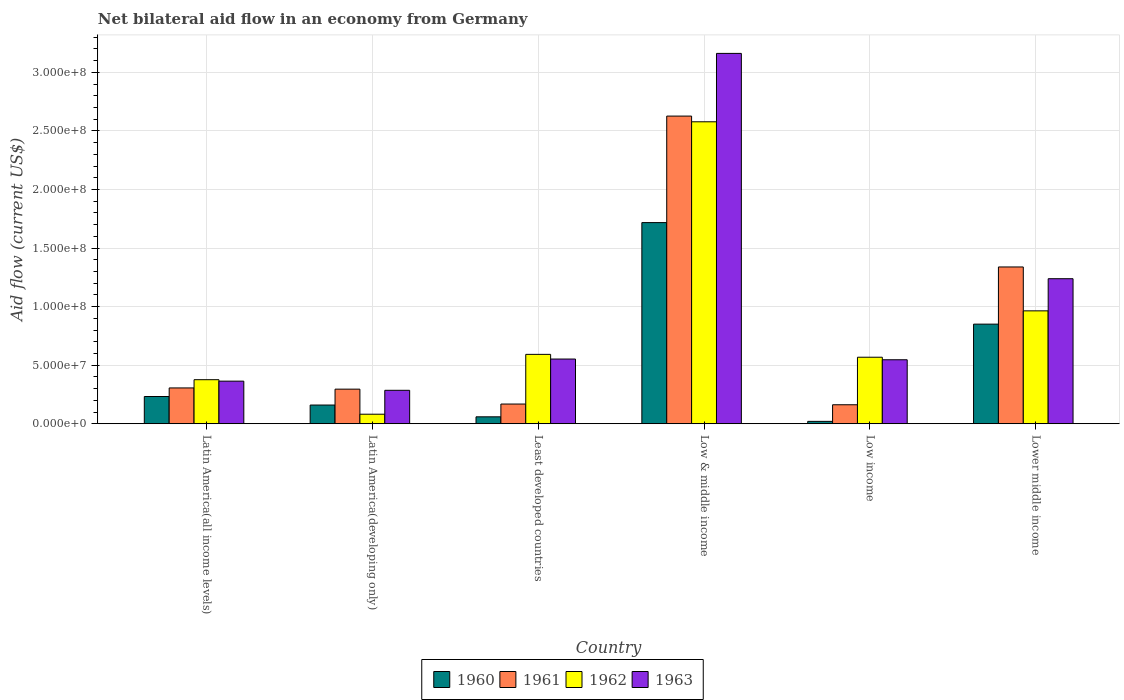How many different coloured bars are there?
Offer a very short reply. 4. How many groups of bars are there?
Ensure brevity in your answer.  6. Are the number of bars per tick equal to the number of legend labels?
Provide a succinct answer. Yes. What is the label of the 1st group of bars from the left?
Your answer should be very brief. Latin America(all income levels). What is the net bilateral aid flow in 1962 in Latin America(developing only)?
Give a very brief answer. 8.13e+06. Across all countries, what is the maximum net bilateral aid flow in 1961?
Your answer should be very brief. 2.63e+08. Across all countries, what is the minimum net bilateral aid flow in 1960?
Your answer should be very brief. 2.02e+06. In which country was the net bilateral aid flow in 1963 maximum?
Provide a short and direct response. Low & middle income. In which country was the net bilateral aid flow in 1963 minimum?
Offer a terse response. Latin America(developing only). What is the total net bilateral aid flow in 1960 in the graph?
Offer a very short reply. 3.04e+08. What is the difference between the net bilateral aid flow in 1962 in Latin America(all income levels) and that in Low income?
Your answer should be compact. -1.92e+07. What is the difference between the net bilateral aid flow in 1960 in Latin America(developing only) and the net bilateral aid flow in 1963 in Low & middle income?
Ensure brevity in your answer.  -3.00e+08. What is the average net bilateral aid flow in 1962 per country?
Provide a short and direct response. 8.60e+07. What is the difference between the net bilateral aid flow of/in 1961 and net bilateral aid flow of/in 1963 in Latin America(all income levels)?
Keep it short and to the point. -5.79e+06. What is the ratio of the net bilateral aid flow in 1962 in Least developed countries to that in Lower middle income?
Your answer should be compact. 0.61. Is the net bilateral aid flow in 1961 in Latin America(all income levels) less than that in Least developed countries?
Ensure brevity in your answer.  No. Is the difference between the net bilateral aid flow in 1961 in Low & middle income and Low income greater than the difference between the net bilateral aid flow in 1963 in Low & middle income and Low income?
Your answer should be very brief. No. What is the difference between the highest and the second highest net bilateral aid flow in 1962?
Provide a short and direct response. 1.99e+08. What is the difference between the highest and the lowest net bilateral aid flow in 1960?
Your answer should be very brief. 1.70e+08. Is it the case that in every country, the sum of the net bilateral aid flow in 1963 and net bilateral aid flow in 1962 is greater than the sum of net bilateral aid flow in 1961 and net bilateral aid flow in 1960?
Provide a succinct answer. No. What does the 2nd bar from the left in Latin America(all income levels) represents?
Your answer should be very brief. 1961. Is it the case that in every country, the sum of the net bilateral aid flow in 1962 and net bilateral aid flow in 1963 is greater than the net bilateral aid flow in 1960?
Give a very brief answer. Yes. Are all the bars in the graph horizontal?
Make the answer very short. No. Are the values on the major ticks of Y-axis written in scientific E-notation?
Give a very brief answer. Yes. Does the graph contain any zero values?
Make the answer very short. No. Does the graph contain grids?
Your answer should be very brief. Yes. How many legend labels are there?
Your answer should be very brief. 4. What is the title of the graph?
Offer a terse response. Net bilateral aid flow in an economy from Germany. What is the label or title of the X-axis?
Your answer should be compact. Country. What is the label or title of the Y-axis?
Keep it short and to the point. Aid flow (current US$). What is the Aid flow (current US$) in 1960 in Latin America(all income levels)?
Give a very brief answer. 2.32e+07. What is the Aid flow (current US$) of 1961 in Latin America(all income levels)?
Make the answer very short. 3.06e+07. What is the Aid flow (current US$) of 1962 in Latin America(all income levels)?
Ensure brevity in your answer.  3.76e+07. What is the Aid flow (current US$) of 1963 in Latin America(all income levels)?
Keep it short and to the point. 3.64e+07. What is the Aid flow (current US$) in 1960 in Latin America(developing only)?
Offer a terse response. 1.60e+07. What is the Aid flow (current US$) of 1961 in Latin America(developing only)?
Make the answer very short. 2.95e+07. What is the Aid flow (current US$) in 1962 in Latin America(developing only)?
Your answer should be compact. 8.13e+06. What is the Aid flow (current US$) of 1963 in Latin America(developing only)?
Your response must be concise. 2.85e+07. What is the Aid flow (current US$) in 1960 in Least developed countries?
Your answer should be compact. 5.90e+06. What is the Aid flow (current US$) of 1961 in Least developed countries?
Provide a short and direct response. 1.68e+07. What is the Aid flow (current US$) in 1962 in Least developed countries?
Provide a short and direct response. 5.92e+07. What is the Aid flow (current US$) of 1963 in Least developed countries?
Give a very brief answer. 5.52e+07. What is the Aid flow (current US$) in 1960 in Low & middle income?
Your response must be concise. 1.72e+08. What is the Aid flow (current US$) in 1961 in Low & middle income?
Your response must be concise. 2.63e+08. What is the Aid flow (current US$) in 1962 in Low & middle income?
Make the answer very short. 2.58e+08. What is the Aid flow (current US$) of 1963 in Low & middle income?
Provide a short and direct response. 3.16e+08. What is the Aid flow (current US$) of 1960 in Low income?
Your answer should be compact. 2.02e+06. What is the Aid flow (current US$) of 1961 in Low income?
Your answer should be very brief. 1.62e+07. What is the Aid flow (current US$) of 1962 in Low income?
Ensure brevity in your answer.  5.68e+07. What is the Aid flow (current US$) in 1963 in Low income?
Offer a very short reply. 5.46e+07. What is the Aid flow (current US$) in 1960 in Lower middle income?
Make the answer very short. 8.50e+07. What is the Aid flow (current US$) in 1961 in Lower middle income?
Make the answer very short. 1.34e+08. What is the Aid flow (current US$) of 1962 in Lower middle income?
Ensure brevity in your answer.  9.64e+07. What is the Aid flow (current US$) of 1963 in Lower middle income?
Give a very brief answer. 1.24e+08. Across all countries, what is the maximum Aid flow (current US$) of 1960?
Keep it short and to the point. 1.72e+08. Across all countries, what is the maximum Aid flow (current US$) in 1961?
Your answer should be very brief. 2.63e+08. Across all countries, what is the maximum Aid flow (current US$) in 1962?
Your answer should be compact. 2.58e+08. Across all countries, what is the maximum Aid flow (current US$) of 1963?
Your response must be concise. 3.16e+08. Across all countries, what is the minimum Aid flow (current US$) of 1960?
Make the answer very short. 2.02e+06. Across all countries, what is the minimum Aid flow (current US$) in 1961?
Provide a short and direct response. 1.62e+07. Across all countries, what is the minimum Aid flow (current US$) in 1962?
Offer a terse response. 8.13e+06. Across all countries, what is the minimum Aid flow (current US$) in 1963?
Give a very brief answer. 2.85e+07. What is the total Aid flow (current US$) in 1960 in the graph?
Offer a very short reply. 3.04e+08. What is the total Aid flow (current US$) in 1961 in the graph?
Provide a short and direct response. 4.90e+08. What is the total Aid flow (current US$) of 1962 in the graph?
Your response must be concise. 5.16e+08. What is the total Aid flow (current US$) in 1963 in the graph?
Give a very brief answer. 6.15e+08. What is the difference between the Aid flow (current US$) of 1960 in Latin America(all income levels) and that in Latin America(developing only)?
Keep it short and to the point. 7.29e+06. What is the difference between the Aid flow (current US$) in 1961 in Latin America(all income levels) and that in Latin America(developing only)?
Offer a very short reply. 1.04e+06. What is the difference between the Aid flow (current US$) of 1962 in Latin America(all income levels) and that in Latin America(developing only)?
Your answer should be compact. 2.95e+07. What is the difference between the Aid flow (current US$) in 1963 in Latin America(all income levels) and that in Latin America(developing only)?
Your answer should be very brief. 7.81e+06. What is the difference between the Aid flow (current US$) of 1960 in Latin America(all income levels) and that in Least developed countries?
Your answer should be very brief. 1.74e+07. What is the difference between the Aid flow (current US$) of 1961 in Latin America(all income levels) and that in Least developed countries?
Make the answer very short. 1.38e+07. What is the difference between the Aid flow (current US$) in 1962 in Latin America(all income levels) and that in Least developed countries?
Offer a very short reply. -2.16e+07. What is the difference between the Aid flow (current US$) of 1963 in Latin America(all income levels) and that in Least developed countries?
Offer a terse response. -1.89e+07. What is the difference between the Aid flow (current US$) of 1960 in Latin America(all income levels) and that in Low & middle income?
Your response must be concise. -1.48e+08. What is the difference between the Aid flow (current US$) of 1961 in Latin America(all income levels) and that in Low & middle income?
Keep it short and to the point. -2.32e+08. What is the difference between the Aid flow (current US$) of 1962 in Latin America(all income levels) and that in Low & middle income?
Keep it short and to the point. -2.20e+08. What is the difference between the Aid flow (current US$) of 1963 in Latin America(all income levels) and that in Low & middle income?
Make the answer very short. -2.80e+08. What is the difference between the Aid flow (current US$) of 1960 in Latin America(all income levels) and that in Low income?
Ensure brevity in your answer.  2.12e+07. What is the difference between the Aid flow (current US$) of 1961 in Latin America(all income levels) and that in Low income?
Offer a terse response. 1.44e+07. What is the difference between the Aid flow (current US$) in 1962 in Latin America(all income levels) and that in Low income?
Your answer should be compact. -1.92e+07. What is the difference between the Aid flow (current US$) of 1963 in Latin America(all income levels) and that in Low income?
Offer a terse response. -1.83e+07. What is the difference between the Aid flow (current US$) of 1960 in Latin America(all income levels) and that in Lower middle income?
Make the answer very short. -6.18e+07. What is the difference between the Aid flow (current US$) in 1961 in Latin America(all income levels) and that in Lower middle income?
Your answer should be compact. -1.03e+08. What is the difference between the Aid flow (current US$) in 1962 in Latin America(all income levels) and that in Lower middle income?
Provide a succinct answer. -5.88e+07. What is the difference between the Aid flow (current US$) of 1963 in Latin America(all income levels) and that in Lower middle income?
Make the answer very short. -8.74e+07. What is the difference between the Aid flow (current US$) of 1960 in Latin America(developing only) and that in Least developed countries?
Ensure brevity in your answer.  1.01e+07. What is the difference between the Aid flow (current US$) in 1961 in Latin America(developing only) and that in Least developed countries?
Your response must be concise. 1.27e+07. What is the difference between the Aid flow (current US$) of 1962 in Latin America(developing only) and that in Least developed countries?
Ensure brevity in your answer.  -5.11e+07. What is the difference between the Aid flow (current US$) of 1963 in Latin America(developing only) and that in Least developed countries?
Give a very brief answer. -2.67e+07. What is the difference between the Aid flow (current US$) in 1960 in Latin America(developing only) and that in Low & middle income?
Provide a short and direct response. -1.56e+08. What is the difference between the Aid flow (current US$) of 1961 in Latin America(developing only) and that in Low & middle income?
Your response must be concise. -2.33e+08. What is the difference between the Aid flow (current US$) in 1962 in Latin America(developing only) and that in Low & middle income?
Ensure brevity in your answer.  -2.50e+08. What is the difference between the Aid flow (current US$) of 1963 in Latin America(developing only) and that in Low & middle income?
Offer a terse response. -2.88e+08. What is the difference between the Aid flow (current US$) in 1960 in Latin America(developing only) and that in Low income?
Ensure brevity in your answer.  1.39e+07. What is the difference between the Aid flow (current US$) of 1961 in Latin America(developing only) and that in Low income?
Keep it short and to the point. 1.33e+07. What is the difference between the Aid flow (current US$) of 1962 in Latin America(developing only) and that in Low income?
Your answer should be very brief. -4.86e+07. What is the difference between the Aid flow (current US$) of 1963 in Latin America(developing only) and that in Low income?
Offer a very short reply. -2.61e+07. What is the difference between the Aid flow (current US$) of 1960 in Latin America(developing only) and that in Lower middle income?
Your answer should be compact. -6.91e+07. What is the difference between the Aid flow (current US$) in 1961 in Latin America(developing only) and that in Lower middle income?
Keep it short and to the point. -1.04e+08. What is the difference between the Aid flow (current US$) in 1962 in Latin America(developing only) and that in Lower middle income?
Your answer should be very brief. -8.82e+07. What is the difference between the Aid flow (current US$) in 1963 in Latin America(developing only) and that in Lower middle income?
Offer a very short reply. -9.53e+07. What is the difference between the Aid flow (current US$) of 1960 in Least developed countries and that in Low & middle income?
Make the answer very short. -1.66e+08. What is the difference between the Aid flow (current US$) in 1961 in Least developed countries and that in Low & middle income?
Offer a terse response. -2.46e+08. What is the difference between the Aid flow (current US$) in 1962 in Least developed countries and that in Low & middle income?
Your response must be concise. -1.99e+08. What is the difference between the Aid flow (current US$) in 1963 in Least developed countries and that in Low & middle income?
Provide a short and direct response. -2.61e+08. What is the difference between the Aid flow (current US$) in 1960 in Least developed countries and that in Low income?
Make the answer very short. 3.88e+06. What is the difference between the Aid flow (current US$) in 1962 in Least developed countries and that in Low income?
Your answer should be compact. 2.45e+06. What is the difference between the Aid flow (current US$) of 1963 in Least developed countries and that in Low income?
Your answer should be very brief. 6.20e+05. What is the difference between the Aid flow (current US$) of 1960 in Least developed countries and that in Lower middle income?
Ensure brevity in your answer.  -7.91e+07. What is the difference between the Aid flow (current US$) in 1961 in Least developed countries and that in Lower middle income?
Make the answer very short. -1.17e+08. What is the difference between the Aid flow (current US$) in 1962 in Least developed countries and that in Lower middle income?
Make the answer very short. -3.71e+07. What is the difference between the Aid flow (current US$) of 1963 in Least developed countries and that in Lower middle income?
Provide a short and direct response. -6.86e+07. What is the difference between the Aid flow (current US$) in 1960 in Low & middle income and that in Low income?
Ensure brevity in your answer.  1.70e+08. What is the difference between the Aid flow (current US$) of 1961 in Low & middle income and that in Low income?
Your response must be concise. 2.46e+08. What is the difference between the Aid flow (current US$) in 1962 in Low & middle income and that in Low income?
Provide a short and direct response. 2.01e+08. What is the difference between the Aid flow (current US$) of 1963 in Low & middle income and that in Low income?
Your response must be concise. 2.62e+08. What is the difference between the Aid flow (current US$) of 1960 in Low & middle income and that in Lower middle income?
Your response must be concise. 8.67e+07. What is the difference between the Aid flow (current US$) in 1961 in Low & middle income and that in Lower middle income?
Provide a short and direct response. 1.29e+08. What is the difference between the Aid flow (current US$) in 1962 in Low & middle income and that in Lower middle income?
Ensure brevity in your answer.  1.61e+08. What is the difference between the Aid flow (current US$) of 1963 in Low & middle income and that in Lower middle income?
Offer a terse response. 1.92e+08. What is the difference between the Aid flow (current US$) of 1960 in Low income and that in Lower middle income?
Provide a short and direct response. -8.30e+07. What is the difference between the Aid flow (current US$) of 1961 in Low income and that in Lower middle income?
Offer a terse response. -1.18e+08. What is the difference between the Aid flow (current US$) of 1962 in Low income and that in Lower middle income?
Your answer should be compact. -3.96e+07. What is the difference between the Aid flow (current US$) in 1963 in Low income and that in Lower middle income?
Offer a very short reply. -6.92e+07. What is the difference between the Aid flow (current US$) of 1960 in Latin America(all income levels) and the Aid flow (current US$) of 1961 in Latin America(developing only)?
Offer a terse response. -6.27e+06. What is the difference between the Aid flow (current US$) in 1960 in Latin America(all income levels) and the Aid flow (current US$) in 1962 in Latin America(developing only)?
Ensure brevity in your answer.  1.51e+07. What is the difference between the Aid flow (current US$) of 1960 in Latin America(all income levels) and the Aid flow (current US$) of 1963 in Latin America(developing only)?
Make the answer very short. -5.29e+06. What is the difference between the Aid flow (current US$) in 1961 in Latin America(all income levels) and the Aid flow (current US$) in 1962 in Latin America(developing only)?
Ensure brevity in your answer.  2.24e+07. What is the difference between the Aid flow (current US$) in 1961 in Latin America(all income levels) and the Aid flow (current US$) in 1963 in Latin America(developing only)?
Give a very brief answer. 2.02e+06. What is the difference between the Aid flow (current US$) of 1962 in Latin America(all income levels) and the Aid flow (current US$) of 1963 in Latin America(developing only)?
Ensure brevity in your answer.  9.05e+06. What is the difference between the Aid flow (current US$) of 1960 in Latin America(all income levels) and the Aid flow (current US$) of 1961 in Least developed countries?
Your answer should be very brief. 6.44e+06. What is the difference between the Aid flow (current US$) of 1960 in Latin America(all income levels) and the Aid flow (current US$) of 1962 in Least developed countries?
Your response must be concise. -3.60e+07. What is the difference between the Aid flow (current US$) in 1960 in Latin America(all income levels) and the Aid flow (current US$) in 1963 in Least developed countries?
Ensure brevity in your answer.  -3.20e+07. What is the difference between the Aid flow (current US$) in 1961 in Latin America(all income levels) and the Aid flow (current US$) in 1962 in Least developed countries?
Make the answer very short. -2.87e+07. What is the difference between the Aid flow (current US$) in 1961 in Latin America(all income levels) and the Aid flow (current US$) in 1963 in Least developed countries?
Make the answer very short. -2.47e+07. What is the difference between the Aid flow (current US$) in 1962 in Latin America(all income levels) and the Aid flow (current US$) in 1963 in Least developed countries?
Ensure brevity in your answer.  -1.76e+07. What is the difference between the Aid flow (current US$) of 1960 in Latin America(all income levels) and the Aid flow (current US$) of 1961 in Low & middle income?
Your answer should be very brief. -2.39e+08. What is the difference between the Aid flow (current US$) of 1960 in Latin America(all income levels) and the Aid flow (current US$) of 1962 in Low & middle income?
Provide a succinct answer. -2.34e+08. What is the difference between the Aid flow (current US$) of 1960 in Latin America(all income levels) and the Aid flow (current US$) of 1963 in Low & middle income?
Offer a terse response. -2.93e+08. What is the difference between the Aid flow (current US$) of 1961 in Latin America(all income levels) and the Aid flow (current US$) of 1962 in Low & middle income?
Offer a very short reply. -2.27e+08. What is the difference between the Aid flow (current US$) of 1961 in Latin America(all income levels) and the Aid flow (current US$) of 1963 in Low & middle income?
Your response must be concise. -2.86e+08. What is the difference between the Aid flow (current US$) of 1962 in Latin America(all income levels) and the Aid flow (current US$) of 1963 in Low & middle income?
Your answer should be very brief. -2.79e+08. What is the difference between the Aid flow (current US$) in 1960 in Latin America(all income levels) and the Aid flow (current US$) in 1961 in Low income?
Your response must be concise. 7.05e+06. What is the difference between the Aid flow (current US$) of 1960 in Latin America(all income levels) and the Aid flow (current US$) of 1962 in Low income?
Provide a succinct answer. -3.35e+07. What is the difference between the Aid flow (current US$) of 1960 in Latin America(all income levels) and the Aid flow (current US$) of 1963 in Low income?
Offer a terse response. -3.14e+07. What is the difference between the Aid flow (current US$) of 1961 in Latin America(all income levels) and the Aid flow (current US$) of 1962 in Low income?
Provide a short and direct response. -2.62e+07. What is the difference between the Aid flow (current US$) of 1961 in Latin America(all income levels) and the Aid flow (current US$) of 1963 in Low income?
Provide a short and direct response. -2.40e+07. What is the difference between the Aid flow (current US$) in 1962 in Latin America(all income levels) and the Aid flow (current US$) in 1963 in Low income?
Ensure brevity in your answer.  -1.70e+07. What is the difference between the Aid flow (current US$) of 1960 in Latin America(all income levels) and the Aid flow (current US$) of 1961 in Lower middle income?
Keep it short and to the point. -1.11e+08. What is the difference between the Aid flow (current US$) in 1960 in Latin America(all income levels) and the Aid flow (current US$) in 1962 in Lower middle income?
Make the answer very short. -7.31e+07. What is the difference between the Aid flow (current US$) of 1960 in Latin America(all income levels) and the Aid flow (current US$) of 1963 in Lower middle income?
Your answer should be compact. -1.01e+08. What is the difference between the Aid flow (current US$) in 1961 in Latin America(all income levels) and the Aid flow (current US$) in 1962 in Lower middle income?
Ensure brevity in your answer.  -6.58e+07. What is the difference between the Aid flow (current US$) of 1961 in Latin America(all income levels) and the Aid flow (current US$) of 1963 in Lower middle income?
Your answer should be compact. -9.32e+07. What is the difference between the Aid flow (current US$) in 1962 in Latin America(all income levels) and the Aid flow (current US$) in 1963 in Lower middle income?
Offer a very short reply. -8.62e+07. What is the difference between the Aid flow (current US$) in 1960 in Latin America(developing only) and the Aid flow (current US$) in 1961 in Least developed countries?
Your answer should be compact. -8.50e+05. What is the difference between the Aid flow (current US$) of 1960 in Latin America(developing only) and the Aid flow (current US$) of 1962 in Least developed countries?
Your answer should be compact. -4.33e+07. What is the difference between the Aid flow (current US$) of 1960 in Latin America(developing only) and the Aid flow (current US$) of 1963 in Least developed countries?
Provide a succinct answer. -3.93e+07. What is the difference between the Aid flow (current US$) of 1961 in Latin America(developing only) and the Aid flow (current US$) of 1962 in Least developed countries?
Offer a terse response. -2.97e+07. What is the difference between the Aid flow (current US$) in 1961 in Latin America(developing only) and the Aid flow (current US$) in 1963 in Least developed countries?
Offer a very short reply. -2.57e+07. What is the difference between the Aid flow (current US$) in 1962 in Latin America(developing only) and the Aid flow (current US$) in 1963 in Least developed countries?
Offer a very short reply. -4.71e+07. What is the difference between the Aid flow (current US$) in 1960 in Latin America(developing only) and the Aid flow (current US$) in 1961 in Low & middle income?
Your answer should be compact. -2.47e+08. What is the difference between the Aid flow (current US$) in 1960 in Latin America(developing only) and the Aid flow (current US$) in 1962 in Low & middle income?
Give a very brief answer. -2.42e+08. What is the difference between the Aid flow (current US$) in 1960 in Latin America(developing only) and the Aid flow (current US$) in 1963 in Low & middle income?
Ensure brevity in your answer.  -3.00e+08. What is the difference between the Aid flow (current US$) of 1961 in Latin America(developing only) and the Aid flow (current US$) of 1962 in Low & middle income?
Offer a terse response. -2.28e+08. What is the difference between the Aid flow (current US$) in 1961 in Latin America(developing only) and the Aid flow (current US$) in 1963 in Low & middle income?
Your answer should be compact. -2.87e+08. What is the difference between the Aid flow (current US$) of 1962 in Latin America(developing only) and the Aid flow (current US$) of 1963 in Low & middle income?
Your answer should be very brief. -3.08e+08. What is the difference between the Aid flow (current US$) in 1960 in Latin America(developing only) and the Aid flow (current US$) in 1962 in Low income?
Offer a very short reply. -4.08e+07. What is the difference between the Aid flow (current US$) of 1960 in Latin America(developing only) and the Aid flow (current US$) of 1963 in Low income?
Your answer should be very brief. -3.86e+07. What is the difference between the Aid flow (current US$) in 1961 in Latin America(developing only) and the Aid flow (current US$) in 1962 in Low income?
Provide a succinct answer. -2.72e+07. What is the difference between the Aid flow (current US$) of 1961 in Latin America(developing only) and the Aid flow (current US$) of 1963 in Low income?
Provide a succinct answer. -2.51e+07. What is the difference between the Aid flow (current US$) of 1962 in Latin America(developing only) and the Aid flow (current US$) of 1963 in Low income?
Provide a short and direct response. -4.65e+07. What is the difference between the Aid flow (current US$) of 1960 in Latin America(developing only) and the Aid flow (current US$) of 1961 in Lower middle income?
Offer a terse response. -1.18e+08. What is the difference between the Aid flow (current US$) in 1960 in Latin America(developing only) and the Aid flow (current US$) in 1962 in Lower middle income?
Provide a succinct answer. -8.04e+07. What is the difference between the Aid flow (current US$) of 1960 in Latin America(developing only) and the Aid flow (current US$) of 1963 in Lower middle income?
Your response must be concise. -1.08e+08. What is the difference between the Aid flow (current US$) in 1961 in Latin America(developing only) and the Aid flow (current US$) in 1962 in Lower middle income?
Provide a succinct answer. -6.68e+07. What is the difference between the Aid flow (current US$) in 1961 in Latin America(developing only) and the Aid flow (current US$) in 1963 in Lower middle income?
Provide a succinct answer. -9.43e+07. What is the difference between the Aid flow (current US$) of 1962 in Latin America(developing only) and the Aid flow (current US$) of 1963 in Lower middle income?
Make the answer very short. -1.16e+08. What is the difference between the Aid flow (current US$) in 1960 in Least developed countries and the Aid flow (current US$) in 1961 in Low & middle income?
Your answer should be compact. -2.57e+08. What is the difference between the Aid flow (current US$) in 1960 in Least developed countries and the Aid flow (current US$) in 1962 in Low & middle income?
Provide a short and direct response. -2.52e+08. What is the difference between the Aid flow (current US$) of 1960 in Least developed countries and the Aid flow (current US$) of 1963 in Low & middle income?
Ensure brevity in your answer.  -3.10e+08. What is the difference between the Aid flow (current US$) of 1961 in Least developed countries and the Aid flow (current US$) of 1962 in Low & middle income?
Keep it short and to the point. -2.41e+08. What is the difference between the Aid flow (current US$) of 1961 in Least developed countries and the Aid flow (current US$) of 1963 in Low & middle income?
Ensure brevity in your answer.  -2.99e+08. What is the difference between the Aid flow (current US$) in 1962 in Least developed countries and the Aid flow (current US$) in 1963 in Low & middle income?
Provide a short and direct response. -2.57e+08. What is the difference between the Aid flow (current US$) in 1960 in Least developed countries and the Aid flow (current US$) in 1961 in Low income?
Your response must be concise. -1.03e+07. What is the difference between the Aid flow (current US$) in 1960 in Least developed countries and the Aid flow (current US$) in 1962 in Low income?
Provide a succinct answer. -5.09e+07. What is the difference between the Aid flow (current US$) in 1960 in Least developed countries and the Aid flow (current US$) in 1963 in Low income?
Provide a short and direct response. -4.87e+07. What is the difference between the Aid flow (current US$) in 1961 in Least developed countries and the Aid flow (current US$) in 1962 in Low income?
Keep it short and to the point. -4.00e+07. What is the difference between the Aid flow (current US$) in 1961 in Least developed countries and the Aid flow (current US$) in 1963 in Low income?
Give a very brief answer. -3.78e+07. What is the difference between the Aid flow (current US$) in 1962 in Least developed countries and the Aid flow (current US$) in 1963 in Low income?
Provide a short and direct response. 4.61e+06. What is the difference between the Aid flow (current US$) in 1960 in Least developed countries and the Aid flow (current US$) in 1961 in Lower middle income?
Your answer should be very brief. -1.28e+08. What is the difference between the Aid flow (current US$) of 1960 in Least developed countries and the Aid flow (current US$) of 1962 in Lower middle income?
Keep it short and to the point. -9.05e+07. What is the difference between the Aid flow (current US$) of 1960 in Least developed countries and the Aid flow (current US$) of 1963 in Lower middle income?
Ensure brevity in your answer.  -1.18e+08. What is the difference between the Aid flow (current US$) in 1961 in Least developed countries and the Aid flow (current US$) in 1962 in Lower middle income?
Your answer should be compact. -7.96e+07. What is the difference between the Aid flow (current US$) in 1961 in Least developed countries and the Aid flow (current US$) in 1963 in Lower middle income?
Provide a succinct answer. -1.07e+08. What is the difference between the Aid flow (current US$) of 1962 in Least developed countries and the Aid flow (current US$) of 1963 in Lower middle income?
Your response must be concise. -6.46e+07. What is the difference between the Aid flow (current US$) of 1960 in Low & middle income and the Aid flow (current US$) of 1961 in Low income?
Your response must be concise. 1.55e+08. What is the difference between the Aid flow (current US$) of 1960 in Low & middle income and the Aid flow (current US$) of 1962 in Low income?
Ensure brevity in your answer.  1.15e+08. What is the difference between the Aid flow (current US$) of 1960 in Low & middle income and the Aid flow (current US$) of 1963 in Low income?
Your response must be concise. 1.17e+08. What is the difference between the Aid flow (current US$) in 1961 in Low & middle income and the Aid flow (current US$) in 1962 in Low income?
Provide a short and direct response. 2.06e+08. What is the difference between the Aid flow (current US$) in 1961 in Low & middle income and the Aid flow (current US$) in 1963 in Low income?
Provide a succinct answer. 2.08e+08. What is the difference between the Aid flow (current US$) in 1962 in Low & middle income and the Aid flow (current US$) in 1963 in Low income?
Offer a very short reply. 2.03e+08. What is the difference between the Aid flow (current US$) of 1960 in Low & middle income and the Aid flow (current US$) of 1961 in Lower middle income?
Your answer should be compact. 3.79e+07. What is the difference between the Aid flow (current US$) in 1960 in Low & middle income and the Aid flow (current US$) in 1962 in Lower middle income?
Your response must be concise. 7.53e+07. What is the difference between the Aid flow (current US$) of 1960 in Low & middle income and the Aid flow (current US$) of 1963 in Lower middle income?
Your answer should be very brief. 4.79e+07. What is the difference between the Aid flow (current US$) of 1961 in Low & middle income and the Aid flow (current US$) of 1962 in Lower middle income?
Your answer should be compact. 1.66e+08. What is the difference between the Aid flow (current US$) in 1961 in Low & middle income and the Aid flow (current US$) in 1963 in Lower middle income?
Provide a short and direct response. 1.39e+08. What is the difference between the Aid flow (current US$) of 1962 in Low & middle income and the Aid flow (current US$) of 1963 in Lower middle income?
Keep it short and to the point. 1.34e+08. What is the difference between the Aid flow (current US$) in 1960 in Low income and the Aid flow (current US$) in 1961 in Lower middle income?
Provide a short and direct response. -1.32e+08. What is the difference between the Aid flow (current US$) in 1960 in Low income and the Aid flow (current US$) in 1962 in Lower middle income?
Ensure brevity in your answer.  -9.43e+07. What is the difference between the Aid flow (current US$) of 1960 in Low income and the Aid flow (current US$) of 1963 in Lower middle income?
Give a very brief answer. -1.22e+08. What is the difference between the Aid flow (current US$) in 1961 in Low income and the Aid flow (current US$) in 1962 in Lower middle income?
Make the answer very short. -8.02e+07. What is the difference between the Aid flow (current US$) of 1961 in Low income and the Aid flow (current US$) of 1963 in Lower middle income?
Provide a short and direct response. -1.08e+08. What is the difference between the Aid flow (current US$) of 1962 in Low income and the Aid flow (current US$) of 1963 in Lower middle income?
Make the answer very short. -6.70e+07. What is the average Aid flow (current US$) in 1960 per country?
Offer a very short reply. 5.06e+07. What is the average Aid flow (current US$) of 1961 per country?
Offer a terse response. 8.16e+07. What is the average Aid flow (current US$) in 1962 per country?
Provide a succinct answer. 8.60e+07. What is the average Aid flow (current US$) in 1963 per country?
Your answer should be compact. 1.02e+08. What is the difference between the Aid flow (current US$) in 1960 and Aid flow (current US$) in 1961 in Latin America(all income levels)?
Your answer should be very brief. -7.31e+06. What is the difference between the Aid flow (current US$) in 1960 and Aid flow (current US$) in 1962 in Latin America(all income levels)?
Provide a succinct answer. -1.43e+07. What is the difference between the Aid flow (current US$) in 1960 and Aid flow (current US$) in 1963 in Latin America(all income levels)?
Provide a short and direct response. -1.31e+07. What is the difference between the Aid flow (current US$) in 1961 and Aid flow (current US$) in 1962 in Latin America(all income levels)?
Provide a succinct answer. -7.03e+06. What is the difference between the Aid flow (current US$) in 1961 and Aid flow (current US$) in 1963 in Latin America(all income levels)?
Provide a short and direct response. -5.79e+06. What is the difference between the Aid flow (current US$) in 1962 and Aid flow (current US$) in 1963 in Latin America(all income levels)?
Offer a very short reply. 1.24e+06. What is the difference between the Aid flow (current US$) of 1960 and Aid flow (current US$) of 1961 in Latin America(developing only)?
Offer a very short reply. -1.36e+07. What is the difference between the Aid flow (current US$) of 1960 and Aid flow (current US$) of 1962 in Latin America(developing only)?
Keep it short and to the point. 7.83e+06. What is the difference between the Aid flow (current US$) of 1960 and Aid flow (current US$) of 1963 in Latin America(developing only)?
Make the answer very short. -1.26e+07. What is the difference between the Aid flow (current US$) in 1961 and Aid flow (current US$) in 1962 in Latin America(developing only)?
Keep it short and to the point. 2.14e+07. What is the difference between the Aid flow (current US$) in 1961 and Aid flow (current US$) in 1963 in Latin America(developing only)?
Your answer should be very brief. 9.80e+05. What is the difference between the Aid flow (current US$) in 1962 and Aid flow (current US$) in 1963 in Latin America(developing only)?
Ensure brevity in your answer.  -2.04e+07. What is the difference between the Aid flow (current US$) in 1960 and Aid flow (current US$) in 1961 in Least developed countries?
Your answer should be very brief. -1.09e+07. What is the difference between the Aid flow (current US$) of 1960 and Aid flow (current US$) of 1962 in Least developed countries?
Your answer should be very brief. -5.33e+07. What is the difference between the Aid flow (current US$) of 1960 and Aid flow (current US$) of 1963 in Least developed countries?
Offer a very short reply. -4.93e+07. What is the difference between the Aid flow (current US$) in 1961 and Aid flow (current US$) in 1962 in Least developed countries?
Ensure brevity in your answer.  -4.24e+07. What is the difference between the Aid flow (current US$) of 1961 and Aid flow (current US$) of 1963 in Least developed countries?
Keep it short and to the point. -3.84e+07. What is the difference between the Aid flow (current US$) of 1962 and Aid flow (current US$) of 1963 in Least developed countries?
Offer a terse response. 3.99e+06. What is the difference between the Aid flow (current US$) of 1960 and Aid flow (current US$) of 1961 in Low & middle income?
Your response must be concise. -9.09e+07. What is the difference between the Aid flow (current US$) of 1960 and Aid flow (current US$) of 1962 in Low & middle income?
Provide a short and direct response. -8.61e+07. What is the difference between the Aid flow (current US$) in 1960 and Aid flow (current US$) in 1963 in Low & middle income?
Offer a terse response. -1.44e+08. What is the difference between the Aid flow (current US$) in 1961 and Aid flow (current US$) in 1962 in Low & middle income?
Offer a very short reply. 4.87e+06. What is the difference between the Aid flow (current US$) in 1961 and Aid flow (current US$) in 1963 in Low & middle income?
Your response must be concise. -5.35e+07. What is the difference between the Aid flow (current US$) of 1962 and Aid flow (current US$) of 1963 in Low & middle income?
Offer a terse response. -5.84e+07. What is the difference between the Aid flow (current US$) of 1960 and Aid flow (current US$) of 1961 in Low income?
Your answer should be compact. -1.42e+07. What is the difference between the Aid flow (current US$) in 1960 and Aid flow (current US$) in 1962 in Low income?
Give a very brief answer. -5.48e+07. What is the difference between the Aid flow (current US$) in 1960 and Aid flow (current US$) in 1963 in Low income?
Offer a very short reply. -5.26e+07. What is the difference between the Aid flow (current US$) in 1961 and Aid flow (current US$) in 1962 in Low income?
Give a very brief answer. -4.06e+07. What is the difference between the Aid flow (current US$) in 1961 and Aid flow (current US$) in 1963 in Low income?
Provide a short and direct response. -3.84e+07. What is the difference between the Aid flow (current US$) of 1962 and Aid flow (current US$) of 1963 in Low income?
Provide a succinct answer. 2.16e+06. What is the difference between the Aid flow (current US$) in 1960 and Aid flow (current US$) in 1961 in Lower middle income?
Keep it short and to the point. -4.88e+07. What is the difference between the Aid flow (current US$) of 1960 and Aid flow (current US$) of 1962 in Lower middle income?
Provide a short and direct response. -1.13e+07. What is the difference between the Aid flow (current US$) of 1960 and Aid flow (current US$) of 1963 in Lower middle income?
Give a very brief answer. -3.88e+07. What is the difference between the Aid flow (current US$) in 1961 and Aid flow (current US$) in 1962 in Lower middle income?
Your response must be concise. 3.75e+07. What is the difference between the Aid flow (current US$) of 1961 and Aid flow (current US$) of 1963 in Lower middle income?
Make the answer very short. 1.00e+07. What is the difference between the Aid flow (current US$) in 1962 and Aid flow (current US$) in 1963 in Lower middle income?
Your answer should be very brief. -2.74e+07. What is the ratio of the Aid flow (current US$) of 1960 in Latin America(all income levels) to that in Latin America(developing only)?
Give a very brief answer. 1.46. What is the ratio of the Aid flow (current US$) in 1961 in Latin America(all income levels) to that in Latin America(developing only)?
Give a very brief answer. 1.04. What is the ratio of the Aid flow (current US$) of 1962 in Latin America(all income levels) to that in Latin America(developing only)?
Provide a short and direct response. 4.62. What is the ratio of the Aid flow (current US$) of 1963 in Latin America(all income levels) to that in Latin America(developing only)?
Give a very brief answer. 1.27. What is the ratio of the Aid flow (current US$) in 1960 in Latin America(all income levels) to that in Least developed countries?
Your answer should be very brief. 3.94. What is the ratio of the Aid flow (current US$) of 1961 in Latin America(all income levels) to that in Least developed countries?
Keep it short and to the point. 1.82. What is the ratio of the Aid flow (current US$) of 1962 in Latin America(all income levels) to that in Least developed countries?
Provide a short and direct response. 0.63. What is the ratio of the Aid flow (current US$) in 1963 in Latin America(all income levels) to that in Least developed countries?
Ensure brevity in your answer.  0.66. What is the ratio of the Aid flow (current US$) of 1960 in Latin America(all income levels) to that in Low & middle income?
Your answer should be very brief. 0.14. What is the ratio of the Aid flow (current US$) of 1961 in Latin America(all income levels) to that in Low & middle income?
Your response must be concise. 0.12. What is the ratio of the Aid flow (current US$) of 1962 in Latin America(all income levels) to that in Low & middle income?
Keep it short and to the point. 0.15. What is the ratio of the Aid flow (current US$) in 1963 in Latin America(all income levels) to that in Low & middle income?
Give a very brief answer. 0.12. What is the ratio of the Aid flow (current US$) in 1960 in Latin America(all income levels) to that in Low income?
Give a very brief answer. 11.51. What is the ratio of the Aid flow (current US$) in 1961 in Latin America(all income levels) to that in Low income?
Ensure brevity in your answer.  1.89. What is the ratio of the Aid flow (current US$) of 1962 in Latin America(all income levels) to that in Low income?
Make the answer very short. 0.66. What is the ratio of the Aid flow (current US$) in 1963 in Latin America(all income levels) to that in Low income?
Your answer should be very brief. 0.67. What is the ratio of the Aid flow (current US$) of 1960 in Latin America(all income levels) to that in Lower middle income?
Your answer should be very brief. 0.27. What is the ratio of the Aid flow (current US$) of 1961 in Latin America(all income levels) to that in Lower middle income?
Ensure brevity in your answer.  0.23. What is the ratio of the Aid flow (current US$) of 1962 in Latin America(all income levels) to that in Lower middle income?
Your response must be concise. 0.39. What is the ratio of the Aid flow (current US$) of 1963 in Latin America(all income levels) to that in Lower middle income?
Provide a short and direct response. 0.29. What is the ratio of the Aid flow (current US$) in 1960 in Latin America(developing only) to that in Least developed countries?
Your answer should be very brief. 2.71. What is the ratio of the Aid flow (current US$) in 1961 in Latin America(developing only) to that in Least developed countries?
Ensure brevity in your answer.  1.76. What is the ratio of the Aid flow (current US$) of 1962 in Latin America(developing only) to that in Least developed countries?
Offer a very short reply. 0.14. What is the ratio of the Aid flow (current US$) of 1963 in Latin America(developing only) to that in Least developed countries?
Provide a short and direct response. 0.52. What is the ratio of the Aid flow (current US$) of 1960 in Latin America(developing only) to that in Low & middle income?
Provide a succinct answer. 0.09. What is the ratio of the Aid flow (current US$) in 1961 in Latin America(developing only) to that in Low & middle income?
Your answer should be compact. 0.11. What is the ratio of the Aid flow (current US$) of 1962 in Latin America(developing only) to that in Low & middle income?
Make the answer very short. 0.03. What is the ratio of the Aid flow (current US$) in 1963 in Latin America(developing only) to that in Low & middle income?
Provide a short and direct response. 0.09. What is the ratio of the Aid flow (current US$) of 1960 in Latin America(developing only) to that in Low income?
Ensure brevity in your answer.  7.9. What is the ratio of the Aid flow (current US$) in 1961 in Latin America(developing only) to that in Low income?
Offer a terse response. 1.82. What is the ratio of the Aid flow (current US$) in 1962 in Latin America(developing only) to that in Low income?
Ensure brevity in your answer.  0.14. What is the ratio of the Aid flow (current US$) in 1963 in Latin America(developing only) to that in Low income?
Offer a terse response. 0.52. What is the ratio of the Aid flow (current US$) of 1960 in Latin America(developing only) to that in Lower middle income?
Your answer should be compact. 0.19. What is the ratio of the Aid flow (current US$) of 1961 in Latin America(developing only) to that in Lower middle income?
Your response must be concise. 0.22. What is the ratio of the Aid flow (current US$) of 1962 in Latin America(developing only) to that in Lower middle income?
Provide a succinct answer. 0.08. What is the ratio of the Aid flow (current US$) in 1963 in Latin America(developing only) to that in Lower middle income?
Make the answer very short. 0.23. What is the ratio of the Aid flow (current US$) of 1960 in Least developed countries to that in Low & middle income?
Provide a succinct answer. 0.03. What is the ratio of the Aid flow (current US$) in 1961 in Least developed countries to that in Low & middle income?
Give a very brief answer. 0.06. What is the ratio of the Aid flow (current US$) in 1962 in Least developed countries to that in Low & middle income?
Ensure brevity in your answer.  0.23. What is the ratio of the Aid flow (current US$) of 1963 in Least developed countries to that in Low & middle income?
Your response must be concise. 0.17. What is the ratio of the Aid flow (current US$) of 1960 in Least developed countries to that in Low income?
Offer a very short reply. 2.92. What is the ratio of the Aid flow (current US$) of 1961 in Least developed countries to that in Low income?
Your response must be concise. 1.04. What is the ratio of the Aid flow (current US$) in 1962 in Least developed countries to that in Low income?
Your response must be concise. 1.04. What is the ratio of the Aid flow (current US$) of 1963 in Least developed countries to that in Low income?
Your answer should be compact. 1.01. What is the ratio of the Aid flow (current US$) of 1960 in Least developed countries to that in Lower middle income?
Provide a short and direct response. 0.07. What is the ratio of the Aid flow (current US$) of 1961 in Least developed countries to that in Lower middle income?
Offer a terse response. 0.13. What is the ratio of the Aid flow (current US$) of 1962 in Least developed countries to that in Lower middle income?
Your response must be concise. 0.61. What is the ratio of the Aid flow (current US$) of 1963 in Least developed countries to that in Lower middle income?
Keep it short and to the point. 0.45. What is the ratio of the Aid flow (current US$) of 1960 in Low & middle income to that in Low income?
Your answer should be compact. 85. What is the ratio of the Aid flow (current US$) in 1961 in Low & middle income to that in Low income?
Your answer should be compact. 16.21. What is the ratio of the Aid flow (current US$) in 1962 in Low & middle income to that in Low income?
Give a very brief answer. 4.54. What is the ratio of the Aid flow (current US$) in 1963 in Low & middle income to that in Low income?
Give a very brief answer. 5.79. What is the ratio of the Aid flow (current US$) in 1960 in Low & middle income to that in Lower middle income?
Make the answer very short. 2.02. What is the ratio of the Aid flow (current US$) of 1961 in Low & middle income to that in Lower middle income?
Your answer should be very brief. 1.96. What is the ratio of the Aid flow (current US$) in 1962 in Low & middle income to that in Lower middle income?
Your answer should be compact. 2.67. What is the ratio of the Aid flow (current US$) in 1963 in Low & middle income to that in Lower middle income?
Offer a terse response. 2.55. What is the ratio of the Aid flow (current US$) in 1960 in Low income to that in Lower middle income?
Give a very brief answer. 0.02. What is the ratio of the Aid flow (current US$) in 1961 in Low income to that in Lower middle income?
Give a very brief answer. 0.12. What is the ratio of the Aid flow (current US$) in 1962 in Low income to that in Lower middle income?
Provide a succinct answer. 0.59. What is the ratio of the Aid flow (current US$) in 1963 in Low income to that in Lower middle income?
Your answer should be compact. 0.44. What is the difference between the highest and the second highest Aid flow (current US$) of 1960?
Keep it short and to the point. 8.67e+07. What is the difference between the highest and the second highest Aid flow (current US$) in 1961?
Your response must be concise. 1.29e+08. What is the difference between the highest and the second highest Aid flow (current US$) of 1962?
Make the answer very short. 1.61e+08. What is the difference between the highest and the second highest Aid flow (current US$) of 1963?
Keep it short and to the point. 1.92e+08. What is the difference between the highest and the lowest Aid flow (current US$) of 1960?
Your response must be concise. 1.70e+08. What is the difference between the highest and the lowest Aid flow (current US$) in 1961?
Provide a succinct answer. 2.46e+08. What is the difference between the highest and the lowest Aid flow (current US$) of 1962?
Make the answer very short. 2.50e+08. What is the difference between the highest and the lowest Aid flow (current US$) in 1963?
Keep it short and to the point. 2.88e+08. 